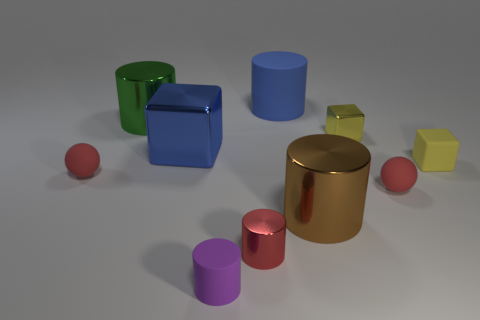Are there any shapes in the image that are reflective, and if so, which ones? Yes, several shapes in the image have reflective surfaces. These include the golden brown cylinder in the center, the green cylinder to the left, the smaller pink cylinder, and the blue cube to the left. Their surfaces are polished enough to exhibit reflections and highlights.  Which shape stands out the most to you and why? The shape that stands out the most to me is the golden brown cylinder in the center of the image. Its reflective metallic finish and central placement draw attention, and its size relative to the other shapes in the image makes it a focal point. 